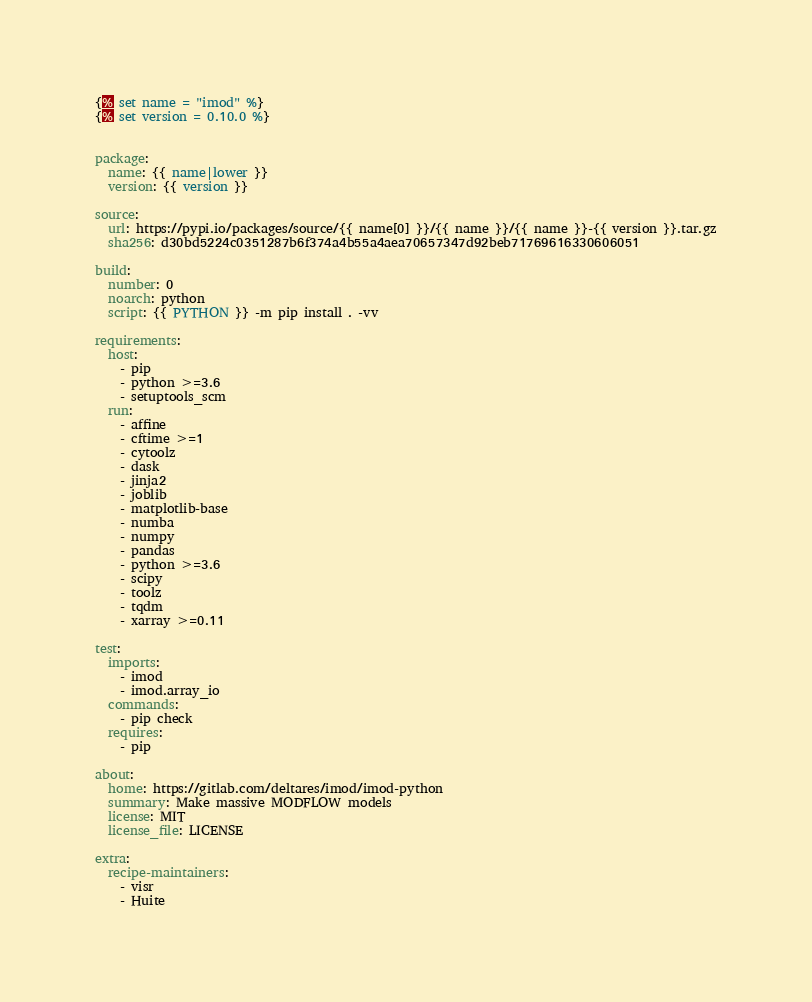<code> <loc_0><loc_0><loc_500><loc_500><_YAML_>{% set name = "imod" %}
{% set version = 0.10.0 %}


package:
  name: {{ name|lower }}
  version: {{ version }}

source:
  url: https://pypi.io/packages/source/{{ name[0] }}/{{ name }}/{{ name }}-{{ version }}.tar.gz
  sha256: d30bd5224c0351287b6f374a4b55a4aea70657347d92beb71769616330606051

build:
  number: 0
  noarch: python
  script: {{ PYTHON }} -m pip install . -vv

requirements:
  host:
    - pip
    - python >=3.6
    - setuptools_scm
  run:
    - affine
    - cftime >=1
    - cytoolz
    - dask
    - jinja2
    - joblib
    - matplotlib-base
    - numba
    - numpy
    - pandas
    - python >=3.6
    - scipy
    - toolz
    - tqdm
    - xarray >=0.11

test:
  imports:
    - imod
    - imod.array_io
  commands:
    - pip check
  requires:
    - pip

about:
  home: https://gitlab.com/deltares/imod/imod-python
  summary: Make massive MODFLOW models
  license: MIT
  license_file: LICENSE

extra:
  recipe-maintainers:
    - visr
    - Huite
</code> 